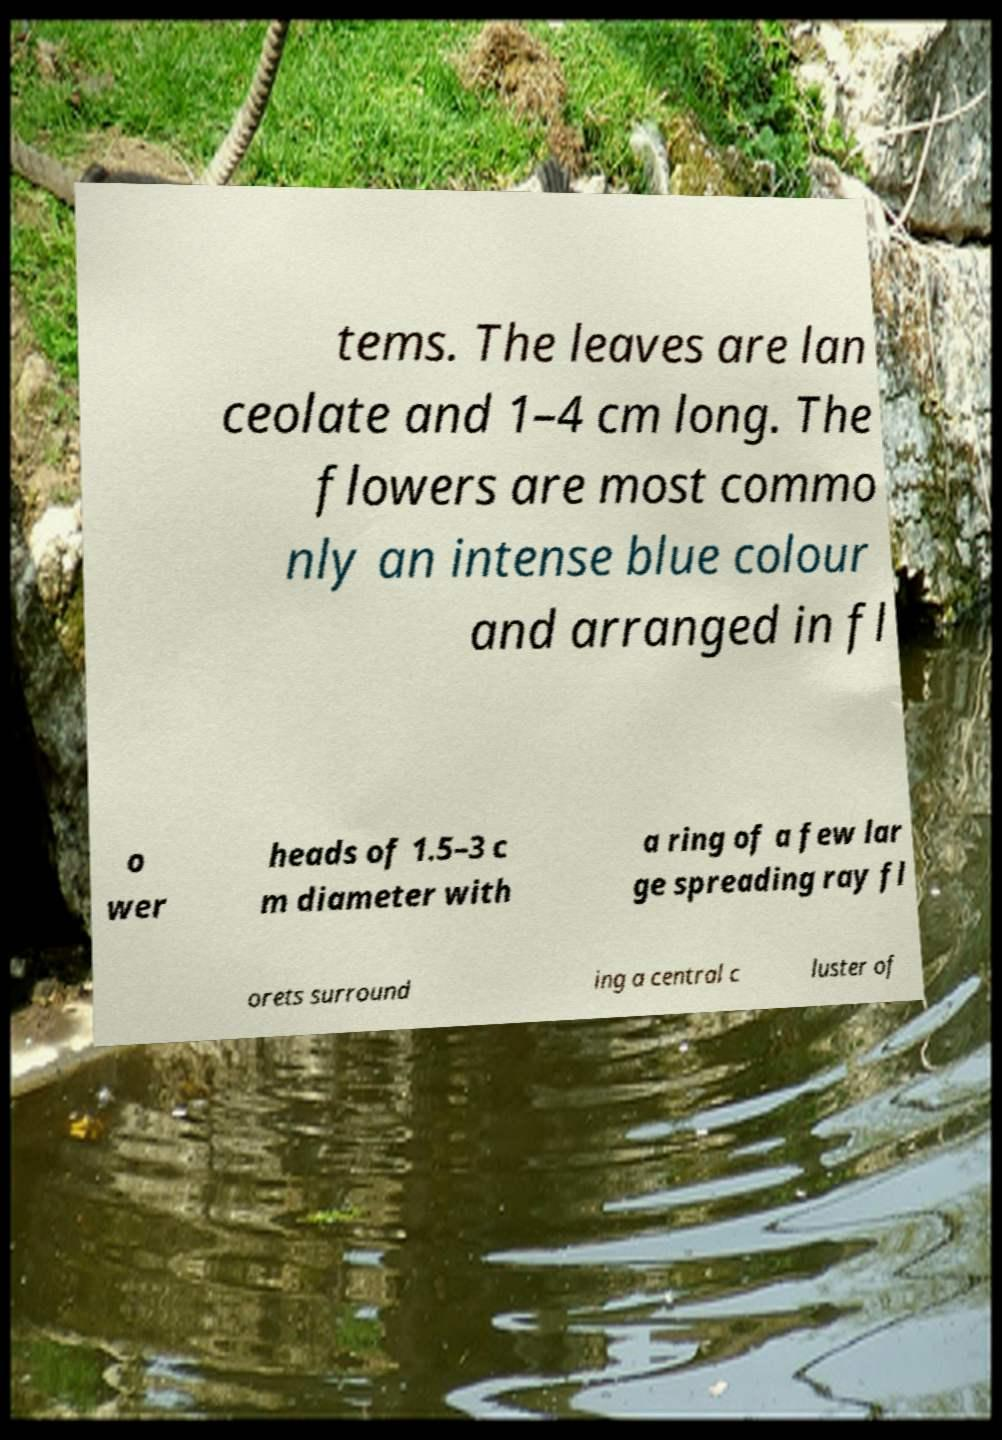Can you accurately transcribe the text from the provided image for me? tems. The leaves are lan ceolate and 1–4 cm long. The flowers are most commo nly an intense blue colour and arranged in fl o wer heads of 1.5–3 c m diameter with a ring of a few lar ge spreading ray fl orets surround ing a central c luster of 